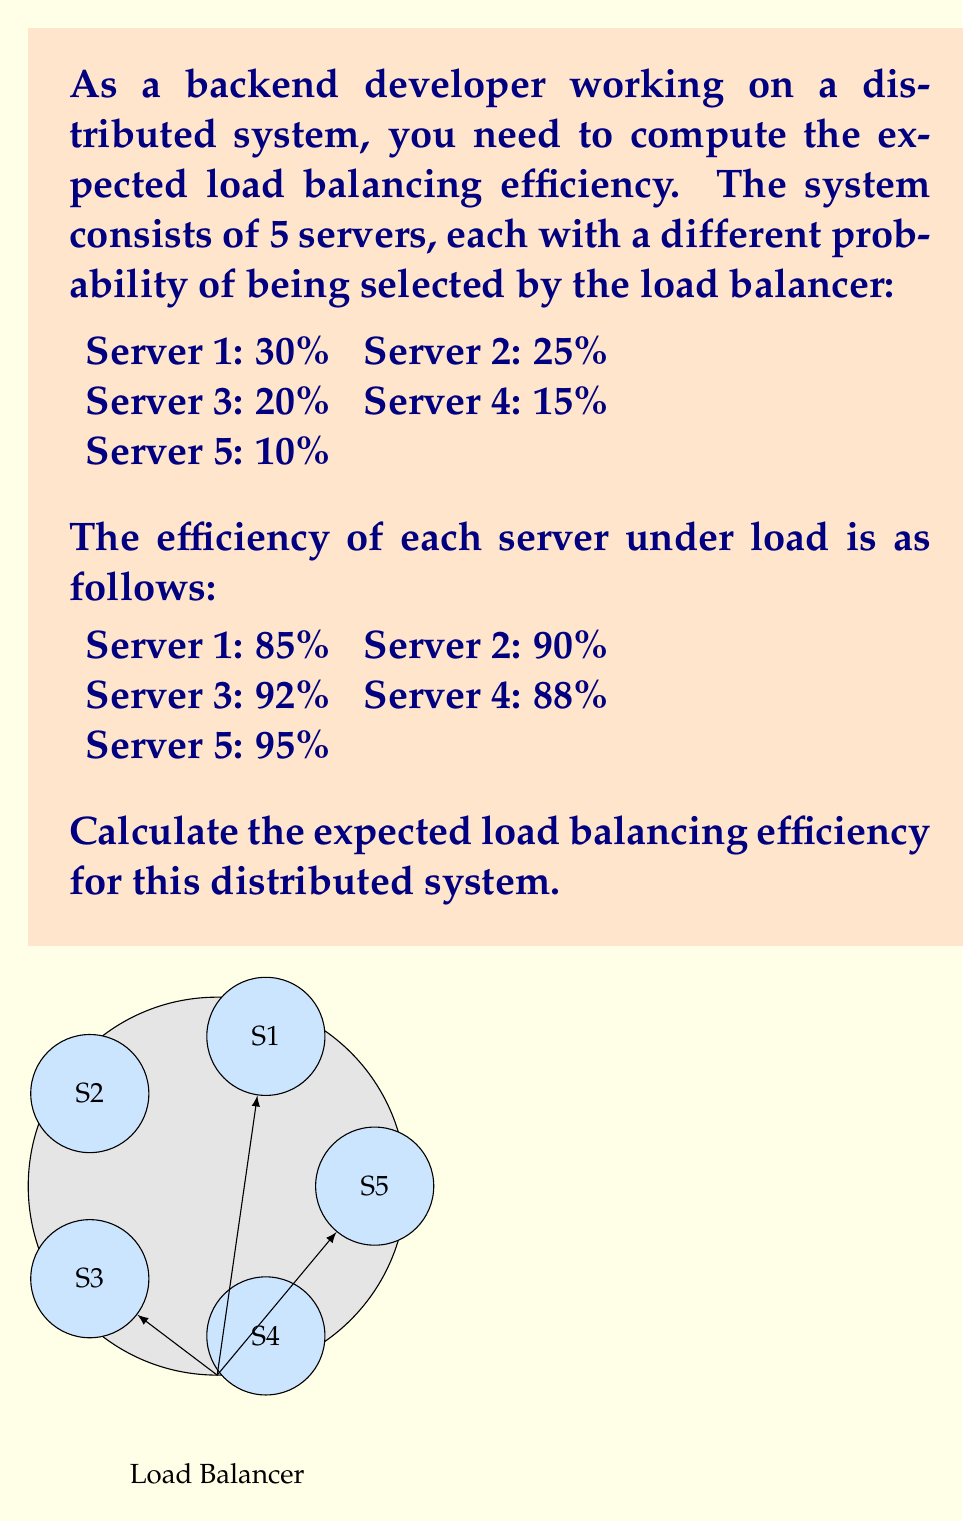Show me your answer to this math problem. To solve this problem, we need to calculate the weighted average of the server efficiencies, where the weights are the probabilities of each server being selected. This is essentially the definition of expected value.

Let's approach this step-by-step:

1) First, let's define our variables:
   $p_i$ = probability of server i being selected
   $e_i$ = efficiency of server i

2) The expected efficiency is given by the formula:
   $E(\text{efficiency}) = \sum_{i=1}^{5} p_i \cdot e_i$

3) Now, let's substitute our values:
   $E(\text{efficiency}) = (0.30 \cdot 0.85) + (0.25 \cdot 0.90) + (0.20 \cdot 0.92) + (0.15 \cdot 0.88) + (0.10 \cdot 0.95)$

4) Let's calculate each term:
   $0.30 \cdot 0.85 = 0.2550$
   $0.25 \cdot 0.90 = 0.2250$
   $0.20 \cdot 0.92 = 0.1840$
   $0.15 \cdot 0.88 = 0.1320$
   $0.10 \cdot 0.95 = 0.0950$

5) Sum up all terms:
   $E(\text{efficiency}) = 0.2550 + 0.2250 + 0.1840 + 0.1320 + 0.0950 = 0.8910$

6) Convert to percentage:
   $0.8910 \cdot 100\% = 89.10\%$

Therefore, the expected load balancing efficiency for this distributed system is 89.10%.
Answer: 89.10% 